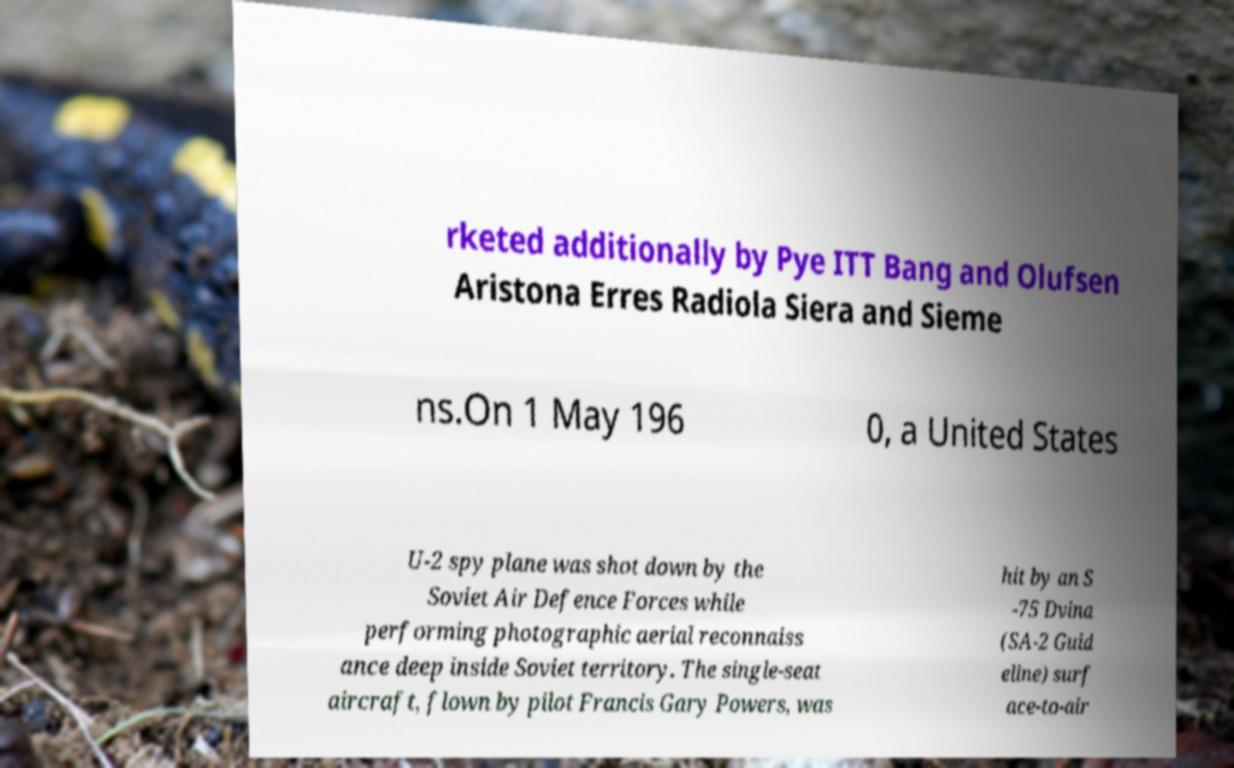Please read and relay the text visible in this image. What does it say? rketed additionally by Pye ITT Bang and Olufsen Aristona Erres Radiola Siera and Sieme ns.On 1 May 196 0, a United States U-2 spy plane was shot down by the Soviet Air Defence Forces while performing photographic aerial reconnaiss ance deep inside Soviet territory. The single-seat aircraft, flown by pilot Francis Gary Powers, was hit by an S -75 Dvina (SA-2 Guid eline) surf ace-to-air 